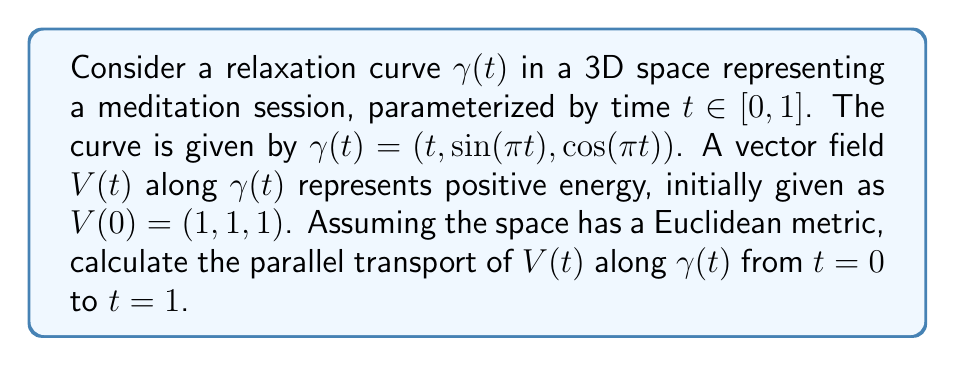Provide a solution to this math problem. To solve this problem, we'll follow these steps:

1) First, we need to calculate the tangent vector $T(t)$ to the curve $\gamma(t)$:
   $$T(t) = \frac{d\gamma}{dt} = (1, \pi\cos(\pi t), -\pi\sin(\pi t))$$

2) For parallel transport in Euclidean space, we need to ensure that the transported vector remains constant in length and angle with respect to the curve. This means we need to solve the parallel transport equation:
   $$\frac{DV}{dt} = \frac{dV}{dt} - \langle\frac{dV}{dt}, T\rangle T = 0$$

3) Let $V(t) = (a(t), b(t), c(t))$. Substituting into the parallel transport equation:
   $$\frac{d}{dt}(a, b, c) - \langle\frac{d}{dt}(a, b, c), (1, \pi\cos(\pi t), -\pi\sin(\pi t))\rangle(1, \pi\cos(\pi t), -\pi\sin(\pi t)) = 0$$

4) This gives us a system of differential equations:
   $$\frac{da}{dt} = 0$$
   $$\frac{db}{dt} = \pi^2\sin(\pi t)c(t)$$
   $$\frac{dc}{dt} = -\pi^2\sin(\pi t)b(t)$$

5) From the first equation, we can see that $a(t) = 1$ (constant).

6) The last two equations form a coupled system. To solve this, we can differentiate the second equation:
   $$\frac{d^2b}{dt^2} = \pi^2\sin(\pi t)\frac{dc}{dt} + \pi^3\cos(\pi t)c(t)$$
   $$= -\pi^4\sin^2(\pi t)b(t) + \pi^3\cos(\pi t)c(t)$$

7) This is a second-order differential equation for $b(t)$. The general solution is:
   $$b(t) = A\cos(\pi t) + B\sin(\pi t)$$
   where $A$ and $B$ are constants.

8) Substituting this back into the equation for $\frac{dc}{dt}$, we get:
   $$c(t) = -A\sin(\pi t) + B\cos(\pi t)$$

9) Using the initial condition $V(0) = (1, 1, 1)$, we can solve for $A$ and $B$:
   $$b(0) = A = 1$$
   $$c(0) = B = 1$$

10) Therefore, the parallel transport of $V(t)$ along $\gamma(t)$ is:
    $$V(t) = (1, \cos(\pi t) + \sin(\pi t), -\sin(\pi t) + \cos(\pi t))$$

11) At $t=1$, we have:
    $$V(1) = (1, \cos(\pi) + \sin(\pi), -\sin(\pi) + \cos(\pi)) = (1, -1, -1)$$
Answer: $(1, -1, -1)$ 